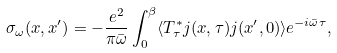Convert formula to latex. <formula><loc_0><loc_0><loc_500><loc_500>\sigma _ { \omega } ( x , x ^ { \prime } ) = - \frac { e ^ { 2 } } { \pi { \bar { \omega } } } \int ^ { \beta } _ { 0 } \langle T _ { \tau } ^ { * } j ( x , \tau ) j ( x ^ { \prime } , 0 ) \rangle e ^ { - i { \bar { \omega } } \tau } ,</formula> 